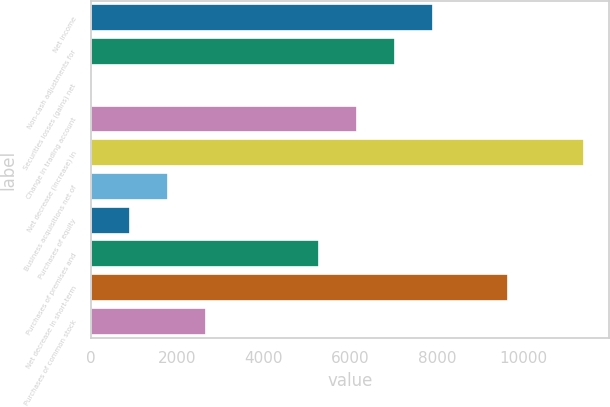<chart> <loc_0><loc_0><loc_500><loc_500><bar_chart><fcel>Net income<fcel>Non-cash adjustments for<fcel>Securities losses (gains) net<fcel>Change in trading account<fcel>Net decrease (increase) in<fcel>Business acquisitions net of<fcel>Purchases of equity<fcel>Purchases of premises and<fcel>Net decrease in short-term<fcel>Purchases of common stock<nl><fcel>7901.9<fcel>7026.8<fcel>26<fcel>6151.7<fcel>11402.3<fcel>1776.2<fcel>901.1<fcel>5276.6<fcel>9652.1<fcel>2651.3<nl></chart> 